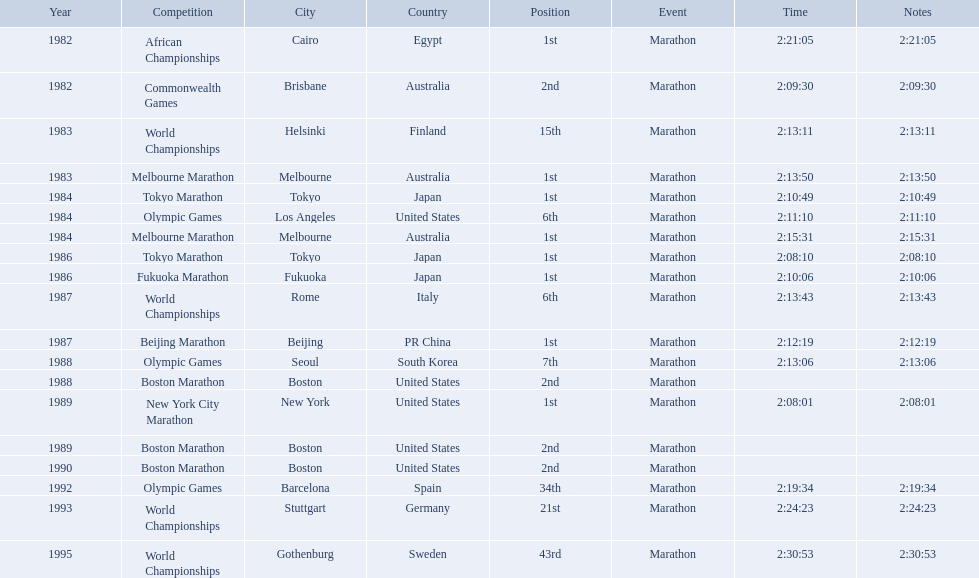What are all the competitions? African Championships, Commonwealth Games, World Championships, Melbourne Marathon, Tokyo Marathon, Olympic Games, Melbourne Marathon, Tokyo Marathon, Fukuoka Marathon, World Championships, Beijing Marathon, Olympic Games, Boston Marathon, New York City Marathon, Boston Marathon, Boston Marathon, Olympic Games, World Championships, World Championships. Where were they located? Cairo, Egypt, Brisbane, Australia, Helsinki, Finland, Melbourne, Australia, Tokyo, Japan, Los Angeles, United States, Melbourne, Australia, Tokyo, Japan, Fukuoka, Japan, Rome, Italy, Beijing, PR China, Seoul, South Korea, Boston, United States, New York, United States, Boston, United States, Boston, United States, Barcelona, Spain, Stuttgart, Germany, Gothenburg, Sweden. And which competition was in china? Beijing Marathon. 